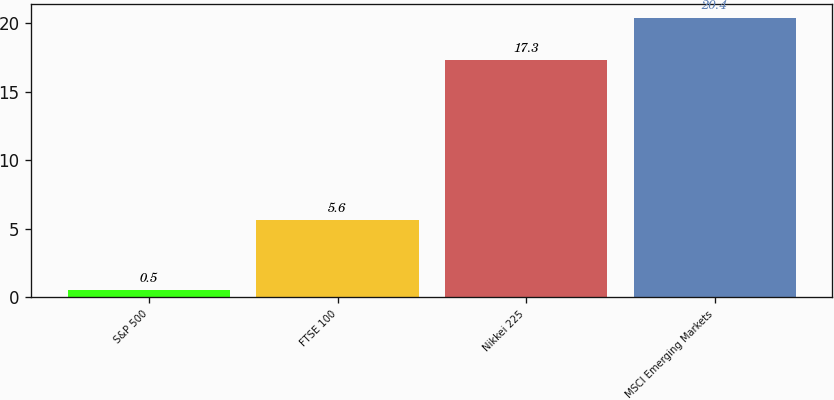Convert chart to OTSL. <chart><loc_0><loc_0><loc_500><loc_500><bar_chart><fcel>S&P 500<fcel>FTSE 100<fcel>Nikkei 225<fcel>MSCI Emerging Markets<nl><fcel>0.5<fcel>5.6<fcel>17.3<fcel>20.4<nl></chart> 